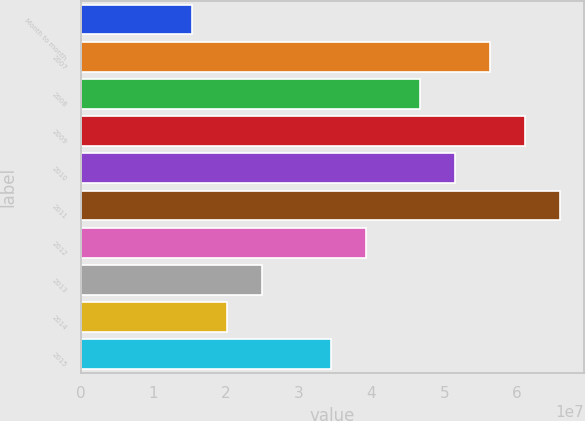Convert chart to OTSL. <chart><loc_0><loc_0><loc_500><loc_500><bar_chart><fcel>Month to month<fcel>2007<fcel>2008<fcel>2009<fcel>2010<fcel>2011<fcel>2012<fcel>2013<fcel>2014<fcel>2015<nl><fcel>1.5307e+07<fcel>5.63106e+07<fcel>4.6727e+07<fcel>6.11024e+07<fcel>5.15188e+07<fcel>6.58942e+07<fcel>3.9266e+07<fcel>2.48906e+07<fcel>2.00988e+07<fcel>3.44742e+07<nl></chart> 